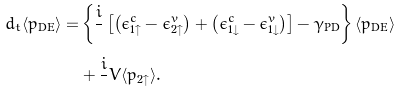<formula> <loc_0><loc_0><loc_500><loc_500>d _ { t } \langle p _ { \text {DE} } \rangle = & \left \{ \frac { i } { } \left [ \left ( \epsilon _ { 1 \uparrow } ^ { c } - \epsilon _ { 2 \uparrow } ^ { v } \right ) + \left ( \epsilon _ { 1 \downarrow } ^ { c } - \epsilon _ { 1 \downarrow } ^ { v } \right ) \right ] - \gamma _ { \text {PD} } \right \} \langle p _ { \text {DE} } \rangle \\ & + \frac { i } { } V \langle p _ { 2 \uparrow } \rangle .</formula> 